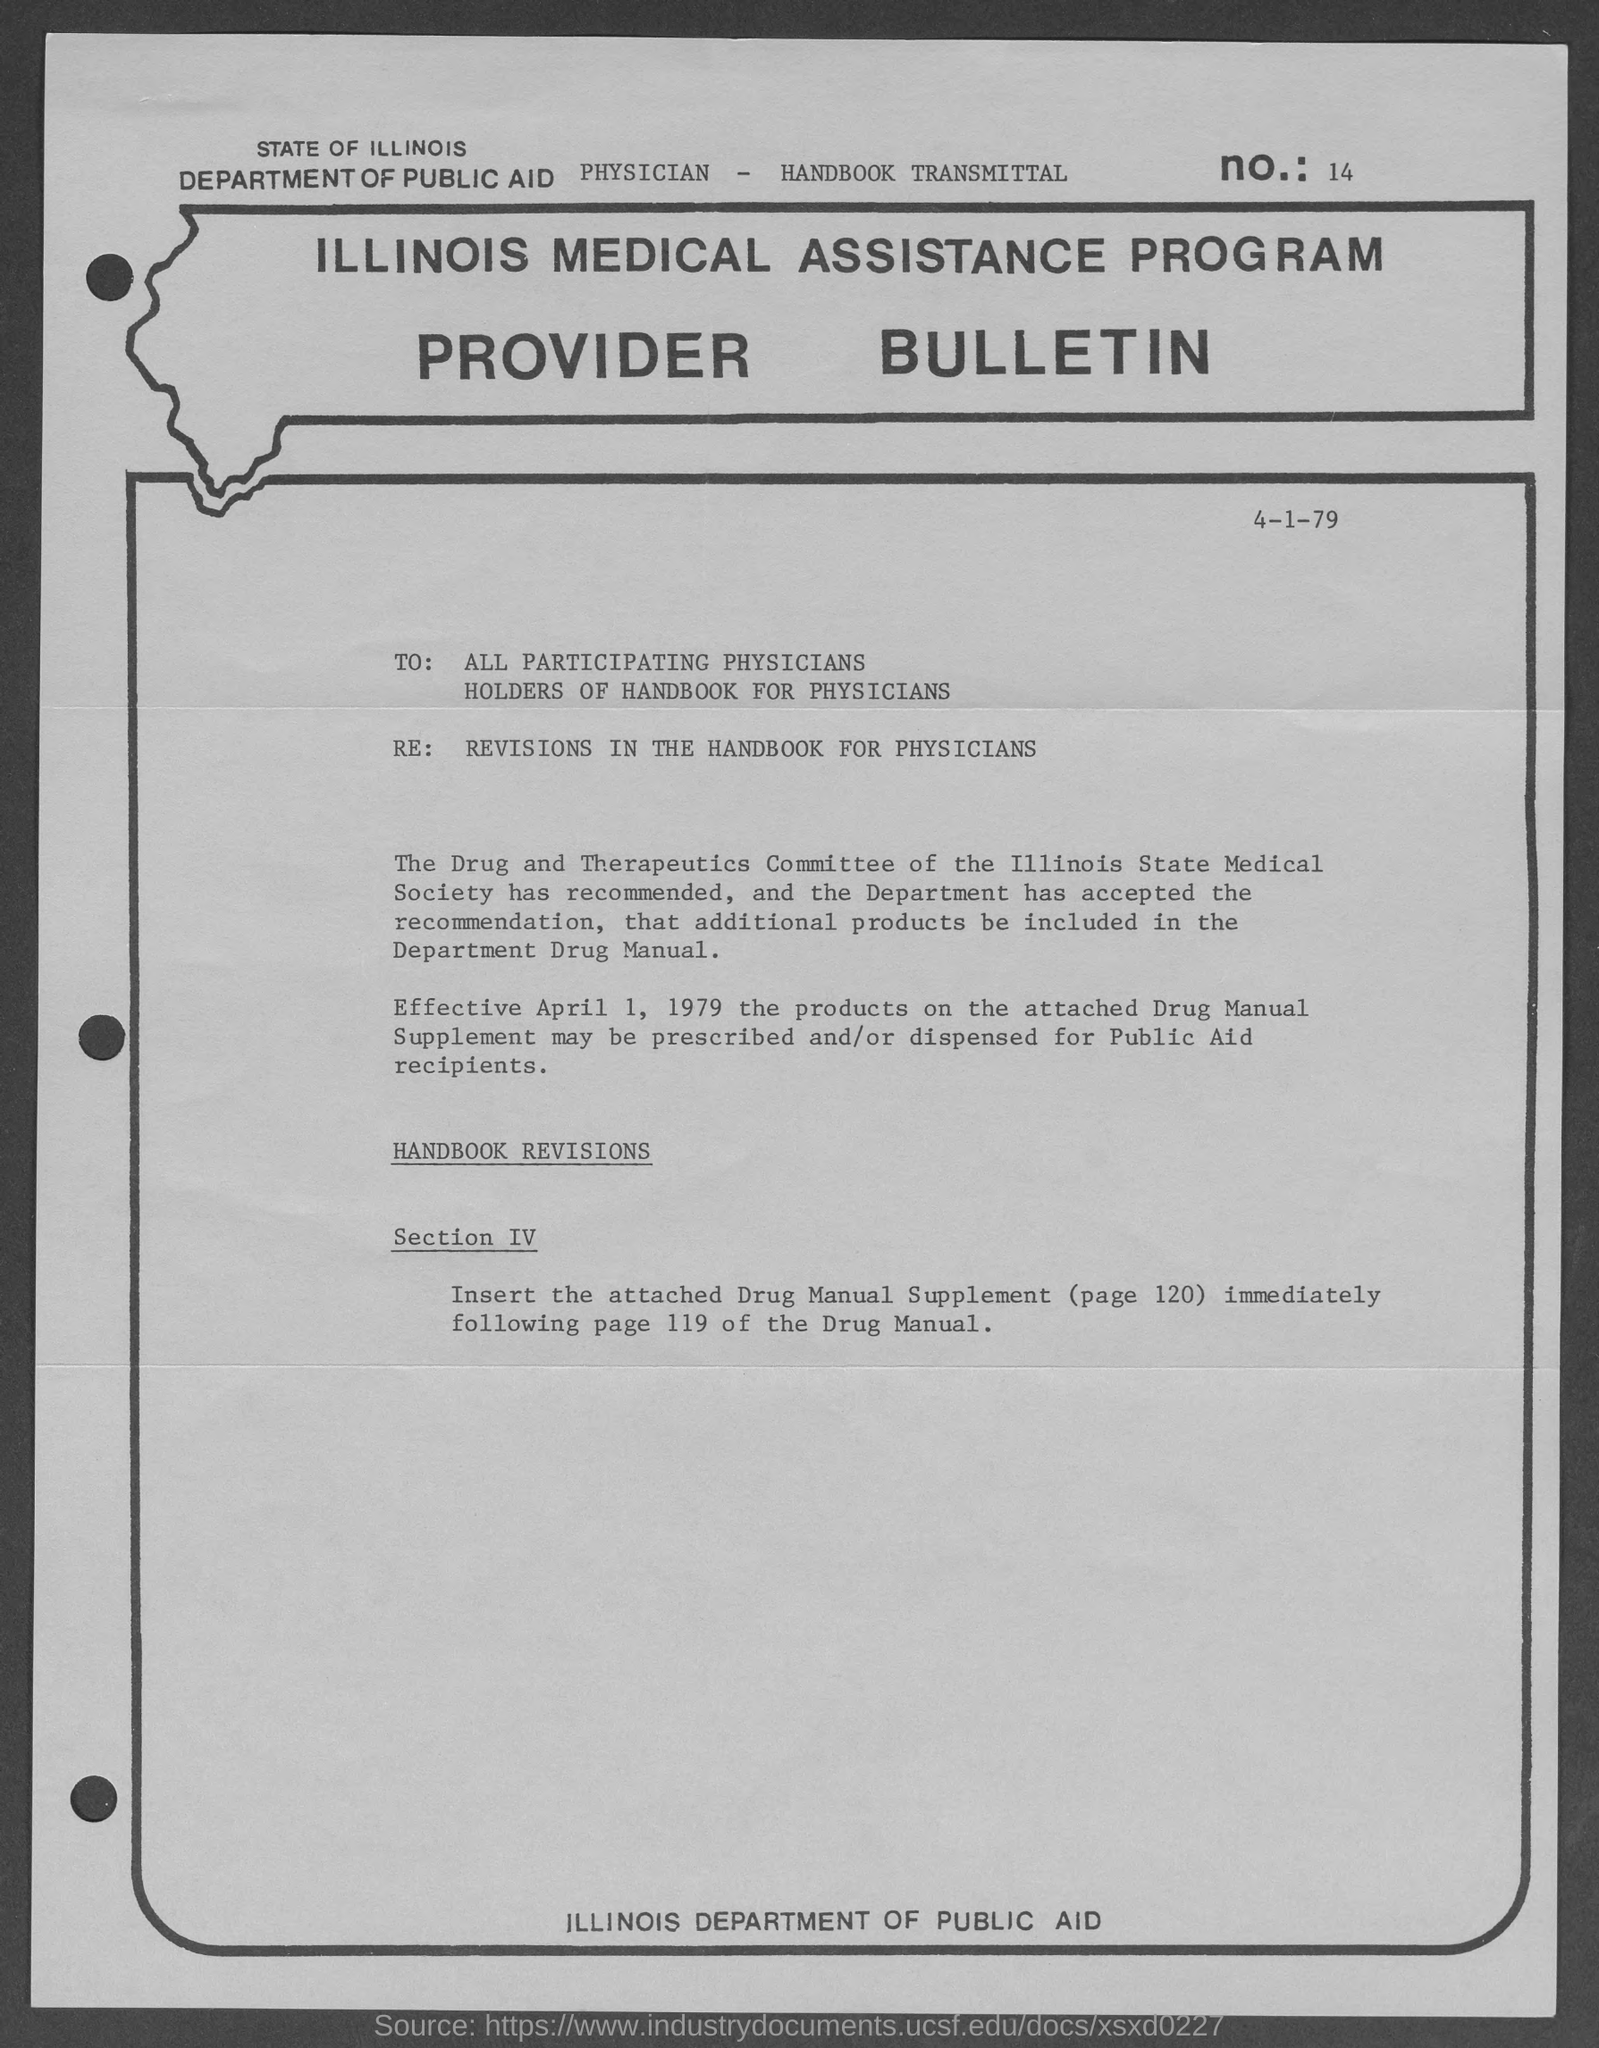What is the date on the document?
Ensure brevity in your answer.  4-1-79. 